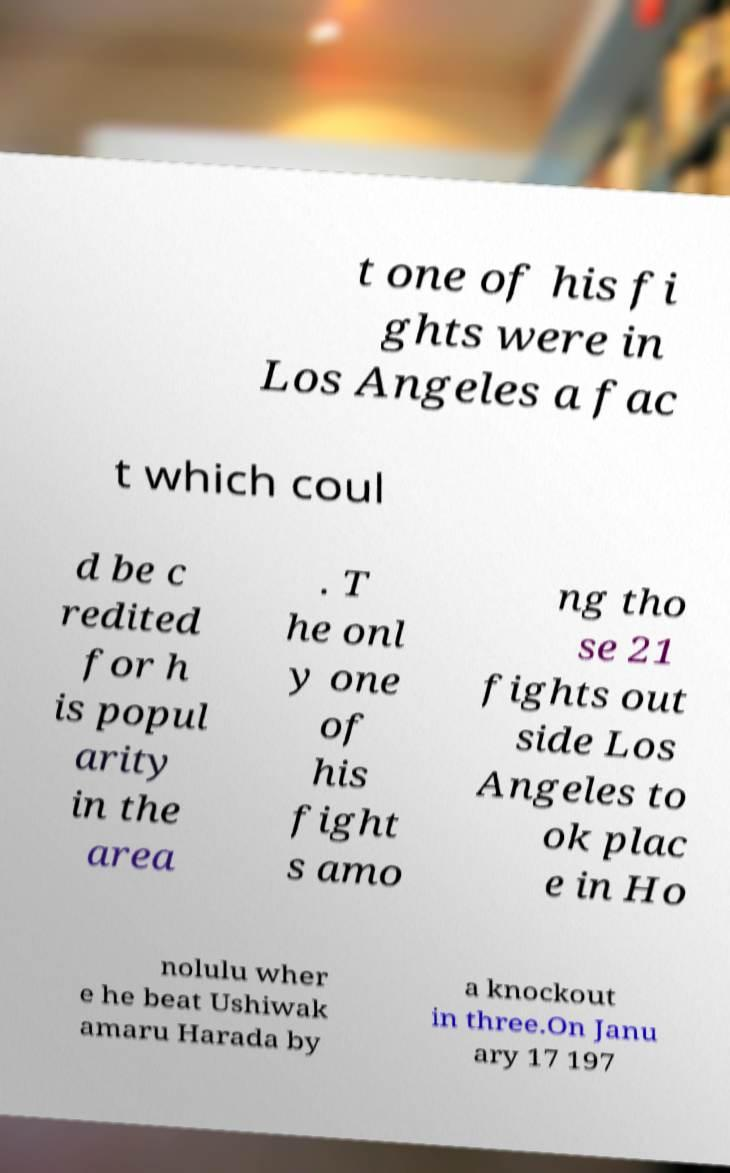Please identify and transcribe the text found in this image. t one of his fi ghts were in Los Angeles a fac t which coul d be c redited for h is popul arity in the area . T he onl y one of his fight s amo ng tho se 21 fights out side Los Angeles to ok plac e in Ho nolulu wher e he beat Ushiwak amaru Harada by a knockout in three.On Janu ary 17 197 